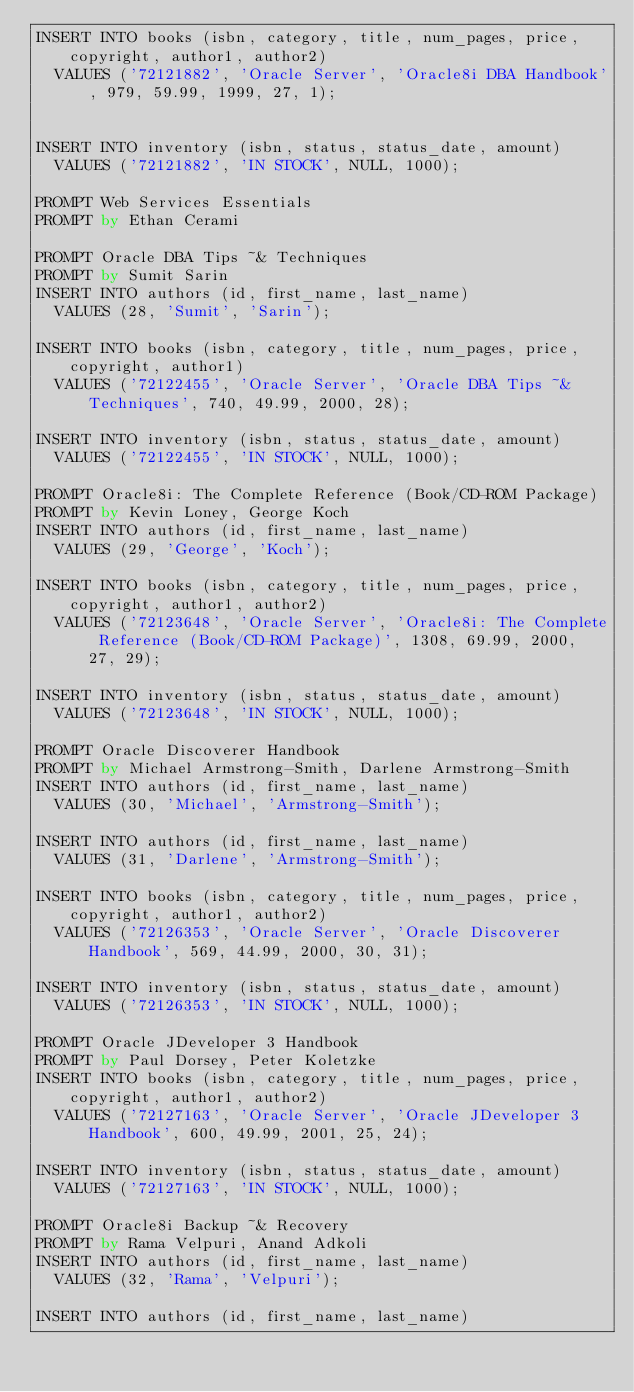Convert code to text. <code><loc_0><loc_0><loc_500><loc_500><_SQL_>INSERT INTO books (isbn, category, title, num_pages, price, copyright, author1, author2)
  VALUES ('72121882', 'Oracle Server', 'Oracle8i DBA Handbook', 979, 59.99, 1999, 27, 1);


INSERT INTO inventory (isbn, status, status_date, amount)
  VALUES ('72121882', 'IN STOCK', NULL, 1000);

PROMPT Web Services Essentials
PROMPT by Ethan Cerami

PROMPT Oracle DBA Tips ~& Techniques
PROMPT by Sumit Sarin
INSERT INTO authors (id, first_name, last_name)
  VALUES (28, 'Sumit', 'Sarin');

INSERT INTO books (isbn, category, title, num_pages, price, copyright, author1)
  VALUES ('72122455', 'Oracle Server', 'Oracle DBA Tips ~& Techniques', 740, 49.99, 2000, 28);

INSERT INTO inventory (isbn, status, status_date, amount)
  VALUES ('72122455', 'IN STOCK', NULL, 1000);

PROMPT Oracle8i: The Complete Reference (Book/CD-ROM Package)
PROMPT by Kevin Loney, George Koch
INSERT INTO authors (id, first_name, last_name)
  VALUES (29, 'George', 'Koch');

INSERT INTO books (isbn, category, title, num_pages, price, copyright, author1, author2)
  VALUES ('72123648', 'Oracle Server', 'Oracle8i: The Complete Reference (Book/CD-ROM Package)', 1308, 69.99, 2000, 27, 29);

INSERT INTO inventory (isbn, status, status_date, amount)
  VALUES ('72123648', 'IN STOCK', NULL, 1000);

PROMPT Oracle Discoverer Handbook
PROMPT by Michael Armstrong-Smith, Darlene Armstrong-Smith
INSERT INTO authors (id, first_name, last_name)
  VALUES (30, 'Michael', 'Armstrong-Smith');

INSERT INTO authors (id, first_name, last_name)
  VALUES (31, 'Darlene', 'Armstrong-Smith');

INSERT INTO books (isbn, category, title, num_pages, price, copyright, author1, author2)
  VALUES ('72126353', 'Oracle Server', 'Oracle Discoverer Handbook', 569, 44.99, 2000, 30, 31);

INSERT INTO inventory (isbn, status, status_date, amount)
  VALUES ('72126353', 'IN STOCK', NULL, 1000);

PROMPT Oracle JDeveloper 3 Handbook
PROMPT by Paul Dorsey, Peter Koletzke
INSERT INTO books (isbn, category, title, num_pages, price, copyright, author1, author2)
  VALUES ('72127163', 'Oracle Server', 'Oracle JDeveloper 3 Handbook', 600, 49.99, 2001, 25, 24);

INSERT INTO inventory (isbn, status, status_date, amount)
  VALUES ('72127163', 'IN STOCK', NULL, 1000);

PROMPT Oracle8i Backup ~& Recovery
PROMPT by Rama Velpuri, Anand Adkoli
INSERT INTO authors (id, first_name, last_name)
  VALUES (32, 'Rama', 'Velpuri');

INSERT INTO authors (id, first_name, last_name)</code> 